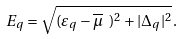Convert formula to latex. <formula><loc_0><loc_0><loc_500><loc_500>E _ { q } = \sqrt { ( \varepsilon _ { q } - \overline { \mu } \ ) ^ { 2 } + | \Delta _ { q } | ^ { 2 } } \, .</formula> 